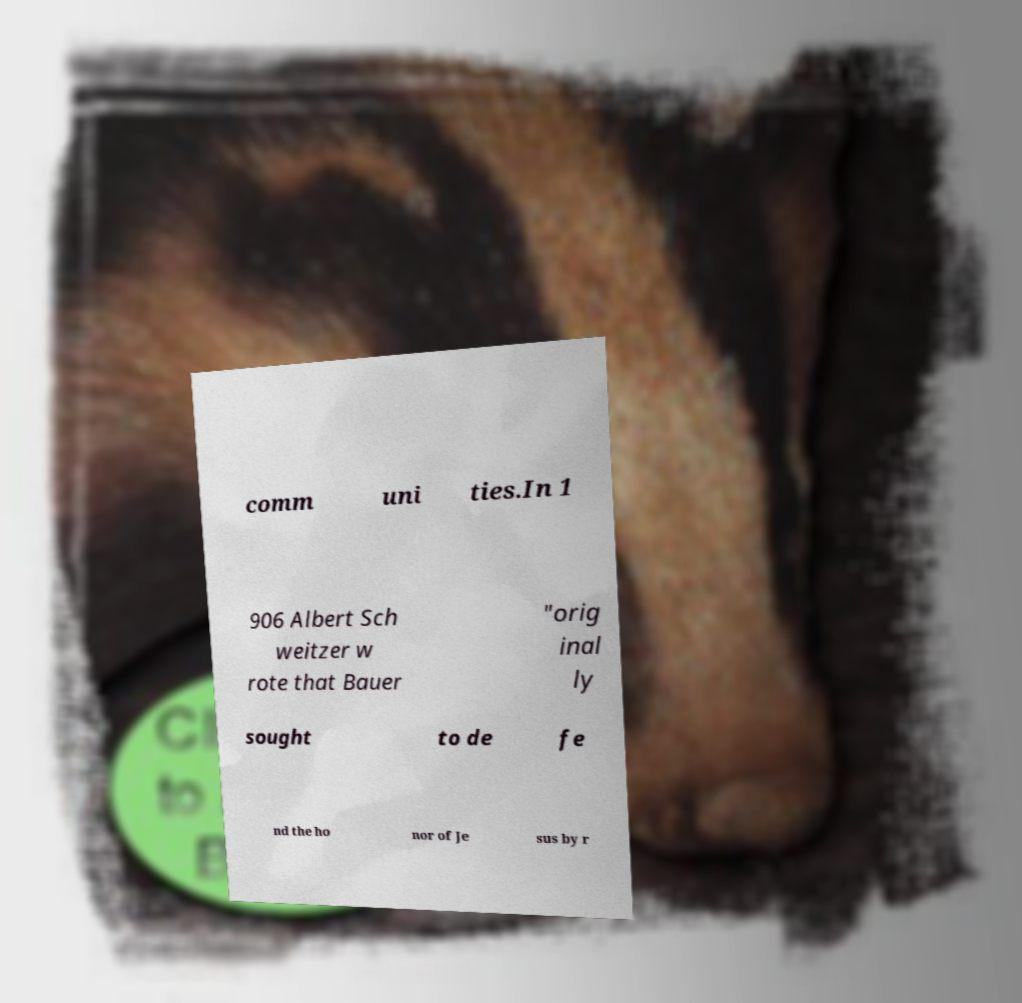Please identify and transcribe the text found in this image. comm uni ties.In 1 906 Albert Sch weitzer w rote that Bauer "orig inal ly sought to de fe nd the ho nor of Je sus by r 